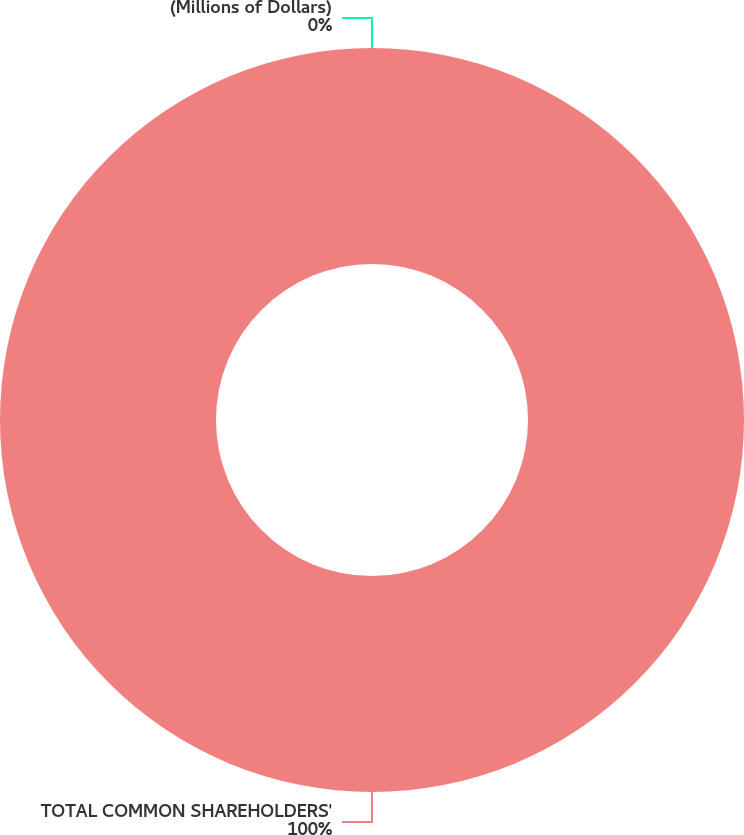<chart> <loc_0><loc_0><loc_500><loc_500><pie_chart><fcel>(Millions of Dollars)<fcel>TOTAL COMMON SHAREHOLDERS'<nl><fcel>0.0%<fcel>100.0%<nl></chart> 